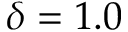<formula> <loc_0><loc_0><loc_500><loc_500>\delta = 1 . 0</formula> 